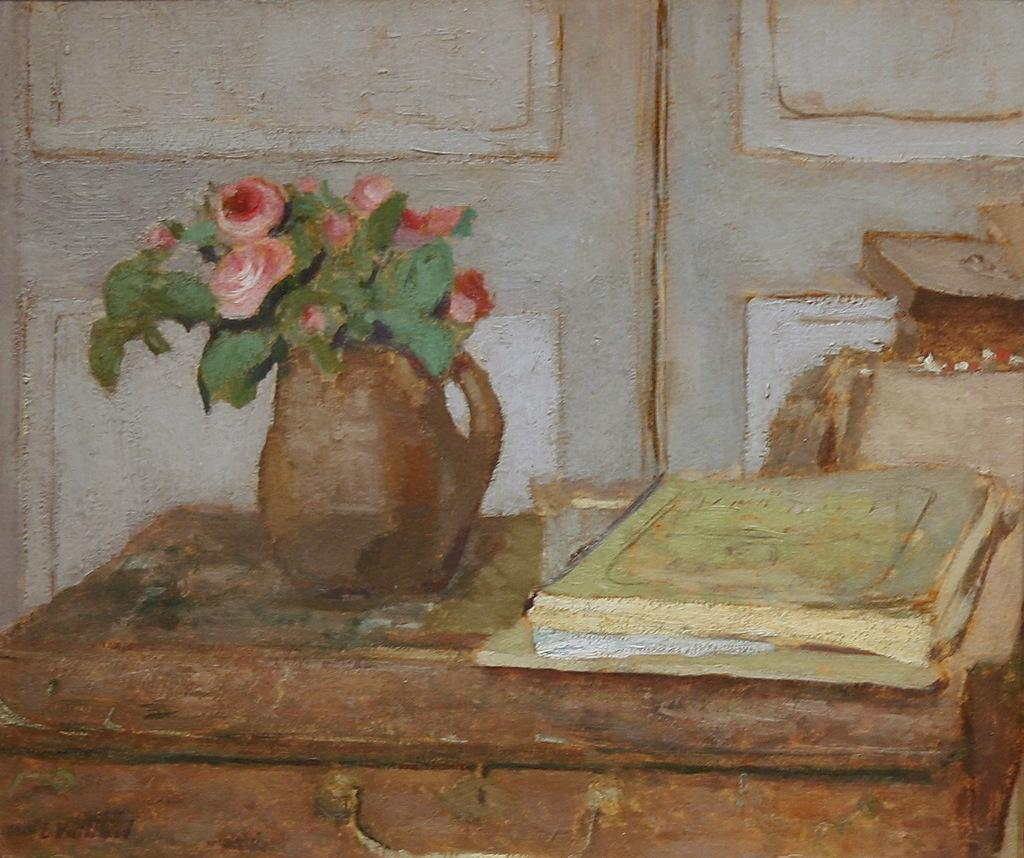What type of artwork is depicted in the image? The image is a painting. What can be seen inside the vase in the painting? There are flowers in a flower vase in the painting. What is the box used for in the painting? There are books on a box in the painting. What architectural feature is visible in the background of the painting? There are doors visible in the background of the painting. Where are the books located on the right side of the painting? There are books on the right side of the painting. How many people are laughing in the painting? There are no people present in the painting, so it is not possible to determine how many are laughing. 